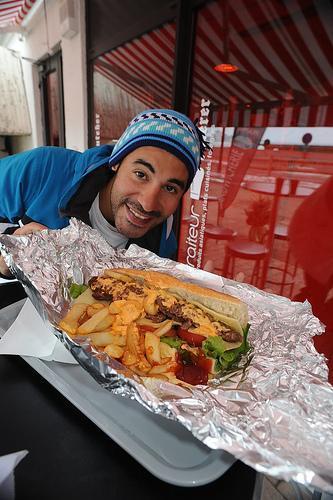How many people?
Give a very brief answer. 1. How many bar stools?
Give a very brief answer. 3. 